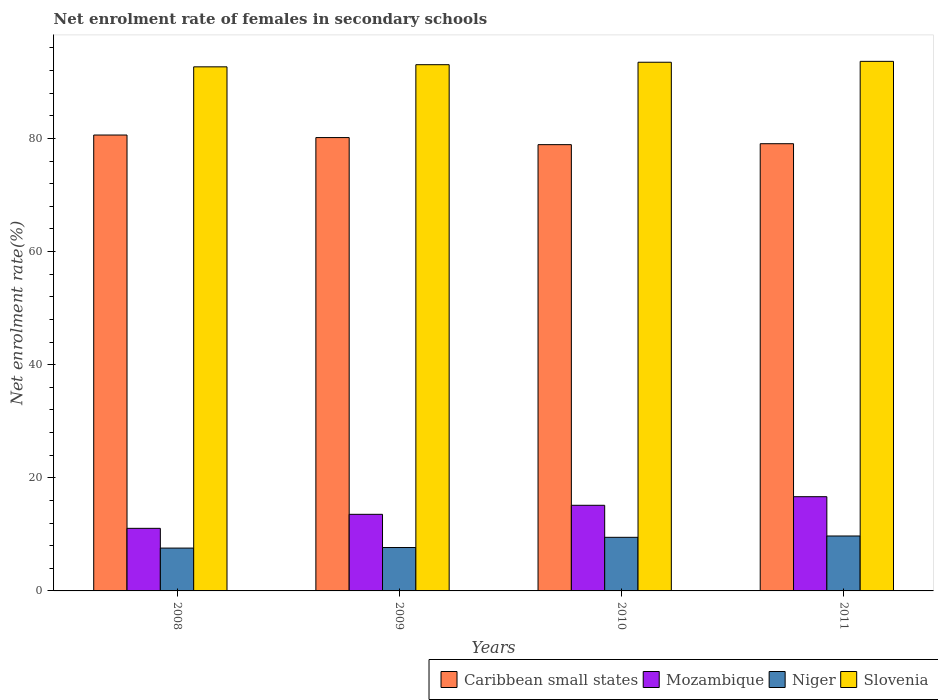What is the label of the 1st group of bars from the left?
Provide a succinct answer. 2008. In how many cases, is the number of bars for a given year not equal to the number of legend labels?
Your answer should be very brief. 0. What is the net enrolment rate of females in secondary schools in Caribbean small states in 2008?
Provide a succinct answer. 80.6. Across all years, what is the maximum net enrolment rate of females in secondary schools in Slovenia?
Give a very brief answer. 93.62. Across all years, what is the minimum net enrolment rate of females in secondary schools in Slovenia?
Offer a terse response. 92.65. In which year was the net enrolment rate of females in secondary schools in Slovenia minimum?
Offer a terse response. 2008. What is the total net enrolment rate of females in secondary schools in Slovenia in the graph?
Your response must be concise. 372.76. What is the difference between the net enrolment rate of females in secondary schools in Niger in 2008 and that in 2011?
Offer a terse response. -2.14. What is the difference between the net enrolment rate of females in secondary schools in Mozambique in 2010 and the net enrolment rate of females in secondary schools in Niger in 2009?
Keep it short and to the point. 7.47. What is the average net enrolment rate of females in secondary schools in Niger per year?
Offer a very short reply. 8.61. In the year 2010, what is the difference between the net enrolment rate of females in secondary schools in Niger and net enrolment rate of females in secondary schools in Slovenia?
Provide a short and direct response. -83.99. What is the ratio of the net enrolment rate of females in secondary schools in Slovenia in 2010 to that in 2011?
Your response must be concise. 1. What is the difference between the highest and the second highest net enrolment rate of females in secondary schools in Slovenia?
Offer a terse response. 0.16. What is the difference between the highest and the lowest net enrolment rate of females in secondary schools in Slovenia?
Make the answer very short. 0.97. Is it the case that in every year, the sum of the net enrolment rate of females in secondary schools in Mozambique and net enrolment rate of females in secondary schools in Niger is greater than the sum of net enrolment rate of females in secondary schools in Caribbean small states and net enrolment rate of females in secondary schools in Slovenia?
Your response must be concise. No. What does the 1st bar from the left in 2011 represents?
Make the answer very short. Caribbean small states. What does the 1st bar from the right in 2010 represents?
Offer a terse response. Slovenia. Is it the case that in every year, the sum of the net enrolment rate of females in secondary schools in Slovenia and net enrolment rate of females in secondary schools in Mozambique is greater than the net enrolment rate of females in secondary schools in Caribbean small states?
Offer a terse response. Yes. Are all the bars in the graph horizontal?
Your answer should be compact. No. What is the difference between two consecutive major ticks on the Y-axis?
Give a very brief answer. 20. Does the graph contain any zero values?
Give a very brief answer. No. Does the graph contain grids?
Provide a short and direct response. No. How many legend labels are there?
Offer a terse response. 4. How are the legend labels stacked?
Give a very brief answer. Horizontal. What is the title of the graph?
Ensure brevity in your answer.  Net enrolment rate of females in secondary schools. What is the label or title of the Y-axis?
Your response must be concise. Net enrolment rate(%). What is the Net enrolment rate(%) of Caribbean small states in 2008?
Keep it short and to the point. 80.6. What is the Net enrolment rate(%) of Mozambique in 2008?
Offer a terse response. 11.06. What is the Net enrolment rate(%) in Niger in 2008?
Your answer should be very brief. 7.57. What is the Net enrolment rate(%) of Slovenia in 2008?
Make the answer very short. 92.65. What is the Net enrolment rate(%) of Caribbean small states in 2009?
Your answer should be very brief. 80.14. What is the Net enrolment rate(%) of Mozambique in 2009?
Your answer should be very brief. 13.54. What is the Net enrolment rate(%) of Niger in 2009?
Make the answer very short. 7.67. What is the Net enrolment rate(%) in Slovenia in 2009?
Provide a short and direct response. 93.03. What is the Net enrolment rate(%) in Caribbean small states in 2010?
Offer a very short reply. 78.89. What is the Net enrolment rate(%) of Mozambique in 2010?
Ensure brevity in your answer.  15.14. What is the Net enrolment rate(%) in Niger in 2010?
Your response must be concise. 9.48. What is the Net enrolment rate(%) in Slovenia in 2010?
Your answer should be very brief. 93.46. What is the Net enrolment rate(%) in Caribbean small states in 2011?
Offer a very short reply. 79.06. What is the Net enrolment rate(%) of Mozambique in 2011?
Your answer should be compact. 16.66. What is the Net enrolment rate(%) in Niger in 2011?
Your answer should be very brief. 9.71. What is the Net enrolment rate(%) of Slovenia in 2011?
Give a very brief answer. 93.62. Across all years, what is the maximum Net enrolment rate(%) in Caribbean small states?
Provide a succinct answer. 80.6. Across all years, what is the maximum Net enrolment rate(%) of Mozambique?
Your response must be concise. 16.66. Across all years, what is the maximum Net enrolment rate(%) in Niger?
Offer a very short reply. 9.71. Across all years, what is the maximum Net enrolment rate(%) in Slovenia?
Make the answer very short. 93.62. Across all years, what is the minimum Net enrolment rate(%) of Caribbean small states?
Your answer should be compact. 78.89. Across all years, what is the minimum Net enrolment rate(%) in Mozambique?
Your response must be concise. 11.06. Across all years, what is the minimum Net enrolment rate(%) in Niger?
Provide a short and direct response. 7.57. Across all years, what is the minimum Net enrolment rate(%) in Slovenia?
Give a very brief answer. 92.65. What is the total Net enrolment rate(%) in Caribbean small states in the graph?
Make the answer very short. 318.69. What is the total Net enrolment rate(%) in Mozambique in the graph?
Keep it short and to the point. 56.4. What is the total Net enrolment rate(%) in Niger in the graph?
Give a very brief answer. 34.43. What is the total Net enrolment rate(%) of Slovenia in the graph?
Provide a short and direct response. 372.76. What is the difference between the Net enrolment rate(%) of Caribbean small states in 2008 and that in 2009?
Make the answer very short. 0.45. What is the difference between the Net enrolment rate(%) of Mozambique in 2008 and that in 2009?
Ensure brevity in your answer.  -2.48. What is the difference between the Net enrolment rate(%) of Niger in 2008 and that in 2009?
Your response must be concise. -0.1. What is the difference between the Net enrolment rate(%) in Slovenia in 2008 and that in 2009?
Keep it short and to the point. -0.38. What is the difference between the Net enrolment rate(%) of Caribbean small states in 2008 and that in 2010?
Give a very brief answer. 1.7. What is the difference between the Net enrolment rate(%) in Mozambique in 2008 and that in 2010?
Your answer should be very brief. -4.07. What is the difference between the Net enrolment rate(%) in Niger in 2008 and that in 2010?
Provide a succinct answer. -1.9. What is the difference between the Net enrolment rate(%) in Slovenia in 2008 and that in 2010?
Your answer should be compact. -0.81. What is the difference between the Net enrolment rate(%) of Caribbean small states in 2008 and that in 2011?
Your response must be concise. 1.54. What is the difference between the Net enrolment rate(%) in Mozambique in 2008 and that in 2011?
Make the answer very short. -5.59. What is the difference between the Net enrolment rate(%) in Niger in 2008 and that in 2011?
Keep it short and to the point. -2.14. What is the difference between the Net enrolment rate(%) of Slovenia in 2008 and that in 2011?
Keep it short and to the point. -0.97. What is the difference between the Net enrolment rate(%) of Caribbean small states in 2009 and that in 2010?
Provide a succinct answer. 1.25. What is the difference between the Net enrolment rate(%) in Mozambique in 2009 and that in 2010?
Your response must be concise. -1.6. What is the difference between the Net enrolment rate(%) in Niger in 2009 and that in 2010?
Provide a short and direct response. -1.8. What is the difference between the Net enrolment rate(%) of Slovenia in 2009 and that in 2010?
Make the answer very short. -0.43. What is the difference between the Net enrolment rate(%) in Caribbean small states in 2009 and that in 2011?
Provide a short and direct response. 1.08. What is the difference between the Net enrolment rate(%) in Mozambique in 2009 and that in 2011?
Make the answer very short. -3.12. What is the difference between the Net enrolment rate(%) of Niger in 2009 and that in 2011?
Give a very brief answer. -2.04. What is the difference between the Net enrolment rate(%) of Slovenia in 2009 and that in 2011?
Offer a very short reply. -0.59. What is the difference between the Net enrolment rate(%) of Caribbean small states in 2010 and that in 2011?
Make the answer very short. -0.17. What is the difference between the Net enrolment rate(%) of Mozambique in 2010 and that in 2011?
Make the answer very short. -1.52. What is the difference between the Net enrolment rate(%) of Niger in 2010 and that in 2011?
Your answer should be very brief. -0.23. What is the difference between the Net enrolment rate(%) of Slovenia in 2010 and that in 2011?
Provide a succinct answer. -0.16. What is the difference between the Net enrolment rate(%) of Caribbean small states in 2008 and the Net enrolment rate(%) of Mozambique in 2009?
Offer a very short reply. 67.05. What is the difference between the Net enrolment rate(%) of Caribbean small states in 2008 and the Net enrolment rate(%) of Niger in 2009?
Provide a succinct answer. 72.92. What is the difference between the Net enrolment rate(%) in Caribbean small states in 2008 and the Net enrolment rate(%) in Slovenia in 2009?
Offer a terse response. -12.43. What is the difference between the Net enrolment rate(%) in Mozambique in 2008 and the Net enrolment rate(%) in Niger in 2009?
Provide a succinct answer. 3.39. What is the difference between the Net enrolment rate(%) in Mozambique in 2008 and the Net enrolment rate(%) in Slovenia in 2009?
Offer a terse response. -81.96. What is the difference between the Net enrolment rate(%) of Niger in 2008 and the Net enrolment rate(%) of Slovenia in 2009?
Make the answer very short. -85.46. What is the difference between the Net enrolment rate(%) in Caribbean small states in 2008 and the Net enrolment rate(%) in Mozambique in 2010?
Make the answer very short. 65.46. What is the difference between the Net enrolment rate(%) of Caribbean small states in 2008 and the Net enrolment rate(%) of Niger in 2010?
Ensure brevity in your answer.  71.12. What is the difference between the Net enrolment rate(%) of Caribbean small states in 2008 and the Net enrolment rate(%) of Slovenia in 2010?
Offer a terse response. -12.87. What is the difference between the Net enrolment rate(%) in Mozambique in 2008 and the Net enrolment rate(%) in Niger in 2010?
Your response must be concise. 1.59. What is the difference between the Net enrolment rate(%) of Mozambique in 2008 and the Net enrolment rate(%) of Slovenia in 2010?
Your response must be concise. -82.4. What is the difference between the Net enrolment rate(%) in Niger in 2008 and the Net enrolment rate(%) in Slovenia in 2010?
Your response must be concise. -85.89. What is the difference between the Net enrolment rate(%) in Caribbean small states in 2008 and the Net enrolment rate(%) in Mozambique in 2011?
Your answer should be very brief. 63.94. What is the difference between the Net enrolment rate(%) of Caribbean small states in 2008 and the Net enrolment rate(%) of Niger in 2011?
Provide a short and direct response. 70.89. What is the difference between the Net enrolment rate(%) in Caribbean small states in 2008 and the Net enrolment rate(%) in Slovenia in 2011?
Your answer should be very brief. -13.02. What is the difference between the Net enrolment rate(%) of Mozambique in 2008 and the Net enrolment rate(%) of Niger in 2011?
Offer a terse response. 1.36. What is the difference between the Net enrolment rate(%) of Mozambique in 2008 and the Net enrolment rate(%) of Slovenia in 2011?
Keep it short and to the point. -82.55. What is the difference between the Net enrolment rate(%) in Niger in 2008 and the Net enrolment rate(%) in Slovenia in 2011?
Your response must be concise. -86.05. What is the difference between the Net enrolment rate(%) in Caribbean small states in 2009 and the Net enrolment rate(%) in Mozambique in 2010?
Your response must be concise. 65.01. What is the difference between the Net enrolment rate(%) in Caribbean small states in 2009 and the Net enrolment rate(%) in Niger in 2010?
Keep it short and to the point. 70.67. What is the difference between the Net enrolment rate(%) in Caribbean small states in 2009 and the Net enrolment rate(%) in Slovenia in 2010?
Offer a terse response. -13.32. What is the difference between the Net enrolment rate(%) in Mozambique in 2009 and the Net enrolment rate(%) in Niger in 2010?
Your answer should be compact. 4.07. What is the difference between the Net enrolment rate(%) of Mozambique in 2009 and the Net enrolment rate(%) of Slovenia in 2010?
Provide a succinct answer. -79.92. What is the difference between the Net enrolment rate(%) of Niger in 2009 and the Net enrolment rate(%) of Slovenia in 2010?
Ensure brevity in your answer.  -85.79. What is the difference between the Net enrolment rate(%) in Caribbean small states in 2009 and the Net enrolment rate(%) in Mozambique in 2011?
Your response must be concise. 63.49. What is the difference between the Net enrolment rate(%) in Caribbean small states in 2009 and the Net enrolment rate(%) in Niger in 2011?
Your answer should be compact. 70.43. What is the difference between the Net enrolment rate(%) of Caribbean small states in 2009 and the Net enrolment rate(%) of Slovenia in 2011?
Your answer should be very brief. -13.47. What is the difference between the Net enrolment rate(%) in Mozambique in 2009 and the Net enrolment rate(%) in Niger in 2011?
Offer a terse response. 3.83. What is the difference between the Net enrolment rate(%) of Mozambique in 2009 and the Net enrolment rate(%) of Slovenia in 2011?
Provide a short and direct response. -80.08. What is the difference between the Net enrolment rate(%) of Niger in 2009 and the Net enrolment rate(%) of Slovenia in 2011?
Ensure brevity in your answer.  -85.95. What is the difference between the Net enrolment rate(%) in Caribbean small states in 2010 and the Net enrolment rate(%) in Mozambique in 2011?
Offer a terse response. 62.24. What is the difference between the Net enrolment rate(%) of Caribbean small states in 2010 and the Net enrolment rate(%) of Niger in 2011?
Give a very brief answer. 69.18. What is the difference between the Net enrolment rate(%) of Caribbean small states in 2010 and the Net enrolment rate(%) of Slovenia in 2011?
Give a very brief answer. -14.72. What is the difference between the Net enrolment rate(%) of Mozambique in 2010 and the Net enrolment rate(%) of Niger in 2011?
Provide a short and direct response. 5.43. What is the difference between the Net enrolment rate(%) of Mozambique in 2010 and the Net enrolment rate(%) of Slovenia in 2011?
Provide a succinct answer. -78.48. What is the difference between the Net enrolment rate(%) in Niger in 2010 and the Net enrolment rate(%) in Slovenia in 2011?
Ensure brevity in your answer.  -84.14. What is the average Net enrolment rate(%) in Caribbean small states per year?
Give a very brief answer. 79.67. What is the average Net enrolment rate(%) in Mozambique per year?
Ensure brevity in your answer.  14.1. What is the average Net enrolment rate(%) of Niger per year?
Your answer should be compact. 8.61. What is the average Net enrolment rate(%) in Slovenia per year?
Provide a succinct answer. 93.19. In the year 2008, what is the difference between the Net enrolment rate(%) of Caribbean small states and Net enrolment rate(%) of Mozambique?
Ensure brevity in your answer.  69.53. In the year 2008, what is the difference between the Net enrolment rate(%) of Caribbean small states and Net enrolment rate(%) of Niger?
Offer a terse response. 73.02. In the year 2008, what is the difference between the Net enrolment rate(%) of Caribbean small states and Net enrolment rate(%) of Slovenia?
Keep it short and to the point. -12.06. In the year 2008, what is the difference between the Net enrolment rate(%) in Mozambique and Net enrolment rate(%) in Niger?
Provide a succinct answer. 3.49. In the year 2008, what is the difference between the Net enrolment rate(%) of Mozambique and Net enrolment rate(%) of Slovenia?
Your response must be concise. -81.59. In the year 2008, what is the difference between the Net enrolment rate(%) in Niger and Net enrolment rate(%) in Slovenia?
Provide a succinct answer. -85.08. In the year 2009, what is the difference between the Net enrolment rate(%) in Caribbean small states and Net enrolment rate(%) in Mozambique?
Your response must be concise. 66.6. In the year 2009, what is the difference between the Net enrolment rate(%) of Caribbean small states and Net enrolment rate(%) of Niger?
Your answer should be compact. 72.47. In the year 2009, what is the difference between the Net enrolment rate(%) in Caribbean small states and Net enrolment rate(%) in Slovenia?
Ensure brevity in your answer.  -12.88. In the year 2009, what is the difference between the Net enrolment rate(%) in Mozambique and Net enrolment rate(%) in Niger?
Your answer should be compact. 5.87. In the year 2009, what is the difference between the Net enrolment rate(%) of Mozambique and Net enrolment rate(%) of Slovenia?
Offer a terse response. -79.49. In the year 2009, what is the difference between the Net enrolment rate(%) of Niger and Net enrolment rate(%) of Slovenia?
Offer a very short reply. -85.35. In the year 2010, what is the difference between the Net enrolment rate(%) in Caribbean small states and Net enrolment rate(%) in Mozambique?
Offer a very short reply. 63.76. In the year 2010, what is the difference between the Net enrolment rate(%) in Caribbean small states and Net enrolment rate(%) in Niger?
Ensure brevity in your answer.  69.42. In the year 2010, what is the difference between the Net enrolment rate(%) in Caribbean small states and Net enrolment rate(%) in Slovenia?
Provide a succinct answer. -14.57. In the year 2010, what is the difference between the Net enrolment rate(%) of Mozambique and Net enrolment rate(%) of Niger?
Your answer should be compact. 5.66. In the year 2010, what is the difference between the Net enrolment rate(%) of Mozambique and Net enrolment rate(%) of Slovenia?
Provide a succinct answer. -78.32. In the year 2010, what is the difference between the Net enrolment rate(%) of Niger and Net enrolment rate(%) of Slovenia?
Your answer should be very brief. -83.99. In the year 2011, what is the difference between the Net enrolment rate(%) in Caribbean small states and Net enrolment rate(%) in Mozambique?
Keep it short and to the point. 62.4. In the year 2011, what is the difference between the Net enrolment rate(%) of Caribbean small states and Net enrolment rate(%) of Niger?
Keep it short and to the point. 69.35. In the year 2011, what is the difference between the Net enrolment rate(%) of Caribbean small states and Net enrolment rate(%) of Slovenia?
Your answer should be very brief. -14.56. In the year 2011, what is the difference between the Net enrolment rate(%) in Mozambique and Net enrolment rate(%) in Niger?
Make the answer very short. 6.95. In the year 2011, what is the difference between the Net enrolment rate(%) in Mozambique and Net enrolment rate(%) in Slovenia?
Your response must be concise. -76.96. In the year 2011, what is the difference between the Net enrolment rate(%) of Niger and Net enrolment rate(%) of Slovenia?
Your answer should be very brief. -83.91. What is the ratio of the Net enrolment rate(%) of Caribbean small states in 2008 to that in 2009?
Provide a succinct answer. 1.01. What is the ratio of the Net enrolment rate(%) of Mozambique in 2008 to that in 2009?
Give a very brief answer. 0.82. What is the ratio of the Net enrolment rate(%) in Slovenia in 2008 to that in 2009?
Make the answer very short. 1. What is the ratio of the Net enrolment rate(%) of Caribbean small states in 2008 to that in 2010?
Make the answer very short. 1.02. What is the ratio of the Net enrolment rate(%) of Mozambique in 2008 to that in 2010?
Offer a very short reply. 0.73. What is the ratio of the Net enrolment rate(%) in Niger in 2008 to that in 2010?
Your answer should be very brief. 0.8. What is the ratio of the Net enrolment rate(%) of Slovenia in 2008 to that in 2010?
Keep it short and to the point. 0.99. What is the ratio of the Net enrolment rate(%) of Caribbean small states in 2008 to that in 2011?
Ensure brevity in your answer.  1.02. What is the ratio of the Net enrolment rate(%) of Mozambique in 2008 to that in 2011?
Keep it short and to the point. 0.66. What is the ratio of the Net enrolment rate(%) in Niger in 2008 to that in 2011?
Give a very brief answer. 0.78. What is the ratio of the Net enrolment rate(%) in Slovenia in 2008 to that in 2011?
Provide a short and direct response. 0.99. What is the ratio of the Net enrolment rate(%) in Caribbean small states in 2009 to that in 2010?
Your answer should be very brief. 1.02. What is the ratio of the Net enrolment rate(%) of Mozambique in 2009 to that in 2010?
Make the answer very short. 0.89. What is the ratio of the Net enrolment rate(%) in Niger in 2009 to that in 2010?
Your response must be concise. 0.81. What is the ratio of the Net enrolment rate(%) in Slovenia in 2009 to that in 2010?
Make the answer very short. 1. What is the ratio of the Net enrolment rate(%) of Caribbean small states in 2009 to that in 2011?
Give a very brief answer. 1.01. What is the ratio of the Net enrolment rate(%) in Mozambique in 2009 to that in 2011?
Your response must be concise. 0.81. What is the ratio of the Net enrolment rate(%) of Niger in 2009 to that in 2011?
Provide a succinct answer. 0.79. What is the ratio of the Net enrolment rate(%) of Caribbean small states in 2010 to that in 2011?
Your answer should be compact. 1. What is the ratio of the Net enrolment rate(%) in Mozambique in 2010 to that in 2011?
Your answer should be compact. 0.91. What is the ratio of the Net enrolment rate(%) in Niger in 2010 to that in 2011?
Your response must be concise. 0.98. What is the ratio of the Net enrolment rate(%) of Slovenia in 2010 to that in 2011?
Your response must be concise. 1. What is the difference between the highest and the second highest Net enrolment rate(%) in Caribbean small states?
Keep it short and to the point. 0.45. What is the difference between the highest and the second highest Net enrolment rate(%) of Mozambique?
Provide a short and direct response. 1.52. What is the difference between the highest and the second highest Net enrolment rate(%) in Niger?
Ensure brevity in your answer.  0.23. What is the difference between the highest and the second highest Net enrolment rate(%) in Slovenia?
Give a very brief answer. 0.16. What is the difference between the highest and the lowest Net enrolment rate(%) in Caribbean small states?
Offer a terse response. 1.7. What is the difference between the highest and the lowest Net enrolment rate(%) in Mozambique?
Offer a very short reply. 5.59. What is the difference between the highest and the lowest Net enrolment rate(%) of Niger?
Keep it short and to the point. 2.14. 